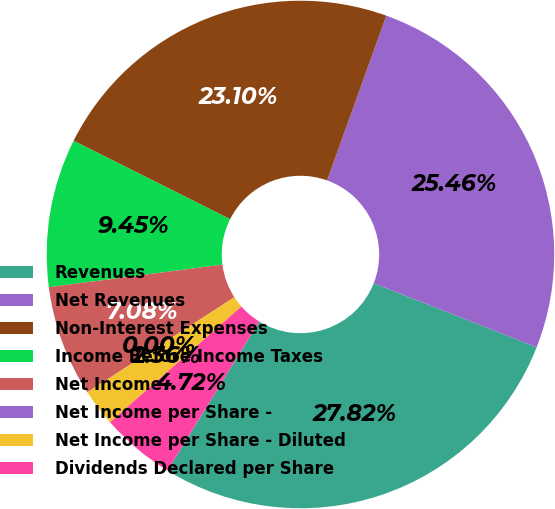Convert chart. <chart><loc_0><loc_0><loc_500><loc_500><pie_chart><fcel>Revenues<fcel>Net Revenues<fcel>Non-Interest Expenses<fcel>Income Before Income Taxes<fcel>Net Income<fcel>Net Income per Share -<fcel>Net Income per Share - Diluted<fcel>Dividends Declared per Share<nl><fcel>27.82%<fcel>25.46%<fcel>23.1%<fcel>9.45%<fcel>7.08%<fcel>0.0%<fcel>2.36%<fcel>4.72%<nl></chart> 